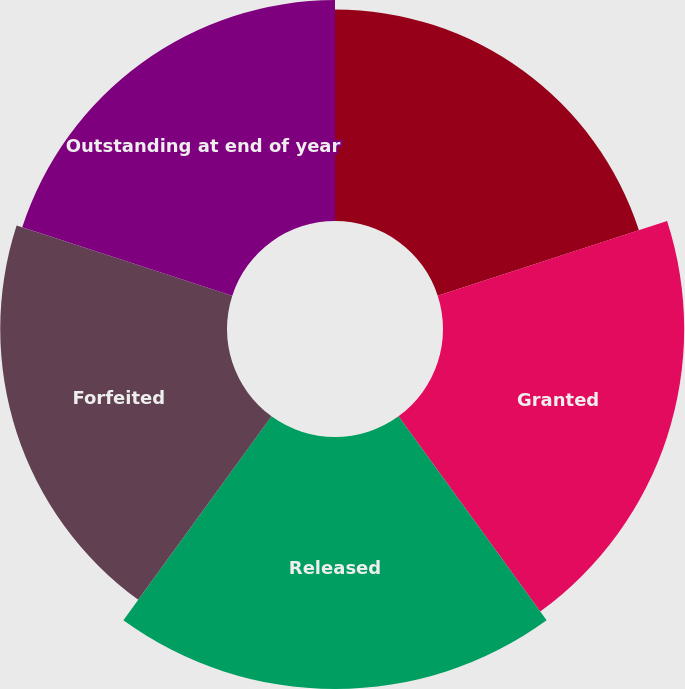<chart> <loc_0><loc_0><loc_500><loc_500><pie_chart><fcel>Outstanding at beginning of<fcel>Granted<fcel>Released<fcel>Forfeited<fcel>Outstanding at end of year<nl><fcel>18.36%<fcel>20.93%<fcel>21.87%<fcel>19.68%<fcel>19.17%<nl></chart> 